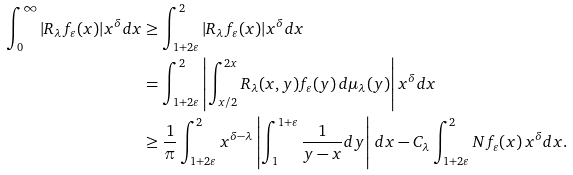<formula> <loc_0><loc_0><loc_500><loc_500>\int _ { 0 } ^ { \infty } | R _ { \lambda } f _ { \varepsilon } ( x ) | x ^ { \delta } d x & \geq \int _ { 1 + 2 \varepsilon } ^ { 2 } | R _ { \lambda } f _ { \varepsilon } ( x ) | x ^ { \delta } d x \\ & = \int _ { 1 + 2 \varepsilon } ^ { 2 } \left | \int _ { x / 2 } ^ { 2 x } R _ { \lambda } ( x , y ) f _ { \varepsilon } ( y ) \, d \mu _ { \lambda } ( y ) \right | x ^ { \delta } d x \\ & \geq \frac { 1 } { \pi } \int _ { 1 + 2 \varepsilon } ^ { 2 } x ^ { \delta - \lambda } \left | \int _ { 1 } ^ { 1 + \varepsilon } \frac { 1 } { y - x } d y \right | \, d x - C _ { \lambda } \int _ { 1 + 2 \varepsilon } ^ { 2 } N f _ { \varepsilon } ( x ) \, x ^ { \delta } d x .</formula> 